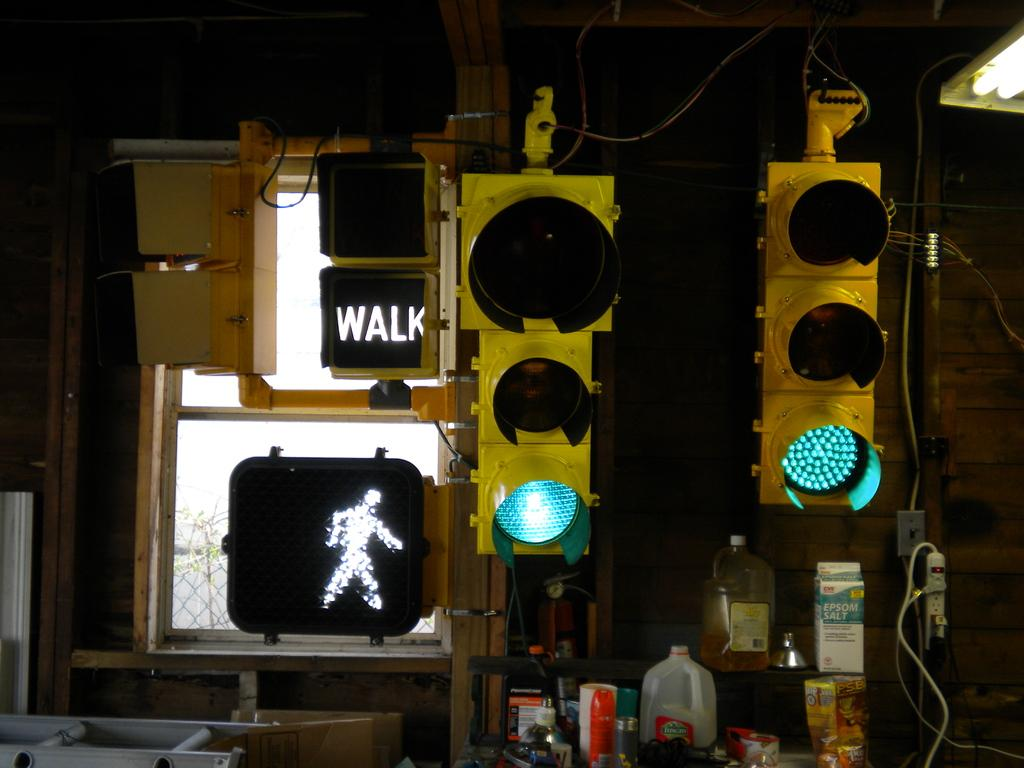<image>
Relay a brief, clear account of the picture shown. A pedestrian signal has the word walk on it in white letters. 